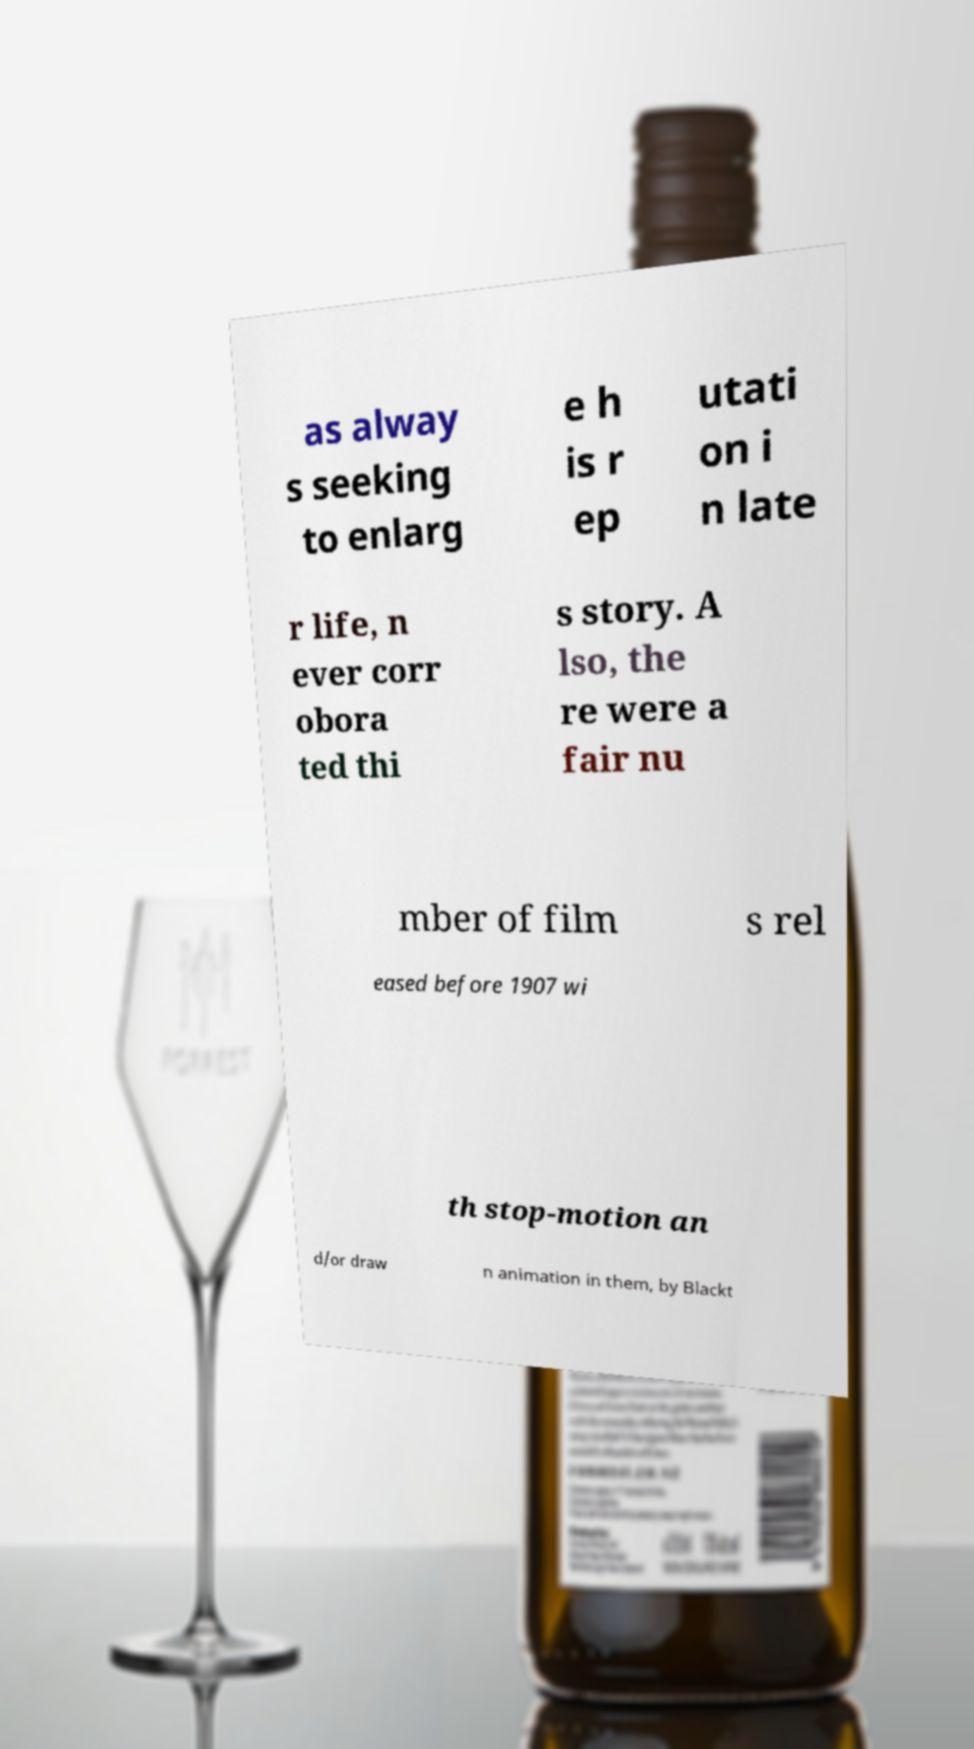What messages or text are displayed in this image? I need them in a readable, typed format. as alway s seeking to enlarg e h is r ep utati on i n late r life, n ever corr obora ted thi s story. A lso, the re were a fair nu mber of film s rel eased before 1907 wi th stop-motion an d/or draw n animation in them, by Blackt 